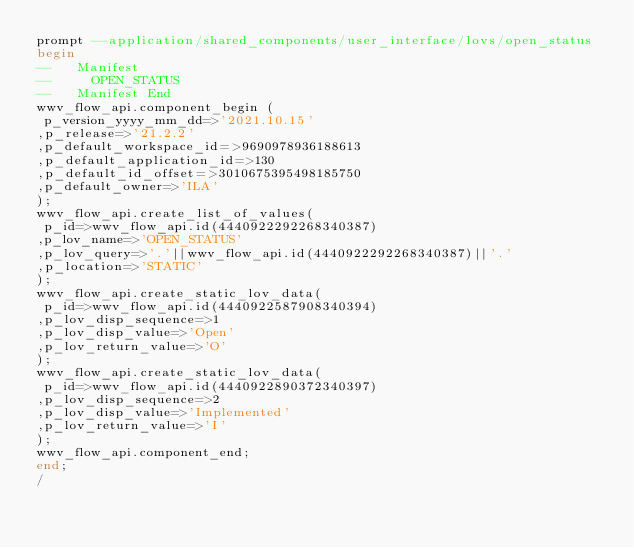Convert code to text. <code><loc_0><loc_0><loc_500><loc_500><_SQL_>prompt --application/shared_components/user_interface/lovs/open_status
begin
--   Manifest
--     OPEN_STATUS
--   Manifest End
wwv_flow_api.component_begin (
 p_version_yyyy_mm_dd=>'2021.10.15'
,p_release=>'21.2.2'
,p_default_workspace_id=>9690978936188613
,p_default_application_id=>130
,p_default_id_offset=>3010675395498185750
,p_default_owner=>'ILA'
);
wwv_flow_api.create_list_of_values(
 p_id=>wwv_flow_api.id(4440922292268340387)
,p_lov_name=>'OPEN_STATUS'
,p_lov_query=>'.'||wwv_flow_api.id(4440922292268340387)||'.'
,p_location=>'STATIC'
);
wwv_flow_api.create_static_lov_data(
 p_id=>wwv_flow_api.id(4440922587908340394)
,p_lov_disp_sequence=>1
,p_lov_disp_value=>'Open'
,p_lov_return_value=>'O'
);
wwv_flow_api.create_static_lov_data(
 p_id=>wwv_flow_api.id(4440922890372340397)
,p_lov_disp_sequence=>2
,p_lov_disp_value=>'Implemented'
,p_lov_return_value=>'I'
);
wwv_flow_api.component_end;
end;
/
</code> 